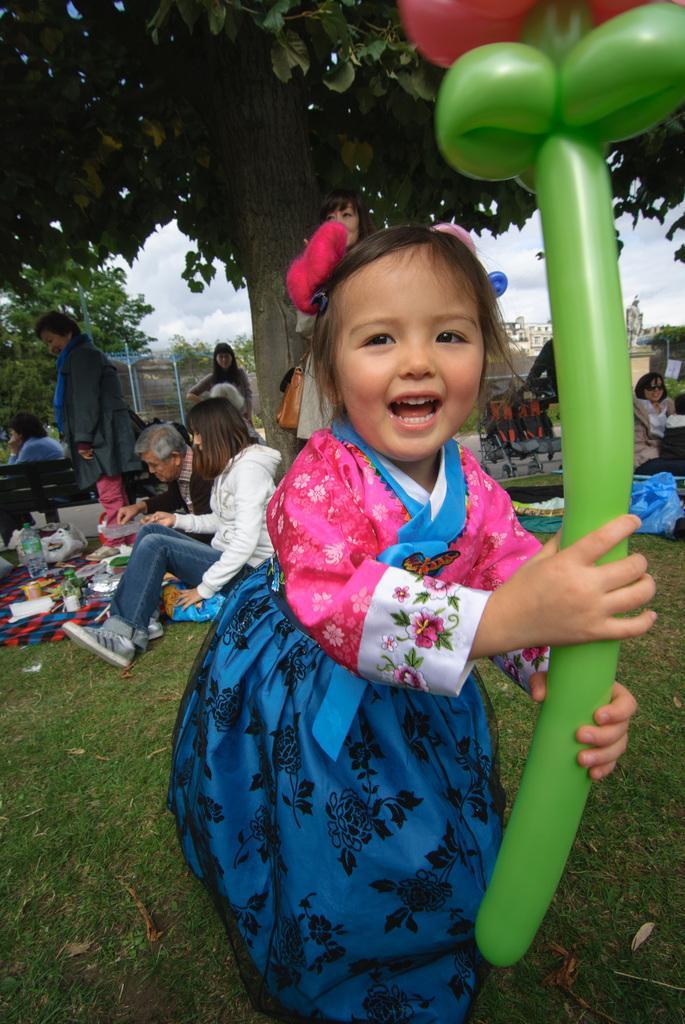Describe this image in one or two sentences. In this image I can see the group of people with different color dresses. I can see these people are under the tree. I can see one person is holding the balloon. To the left I can see the bottle and some objects on the cloth and the cloth is on the grass. In the background I can see many trees, building, statue, clouds and the sky. 